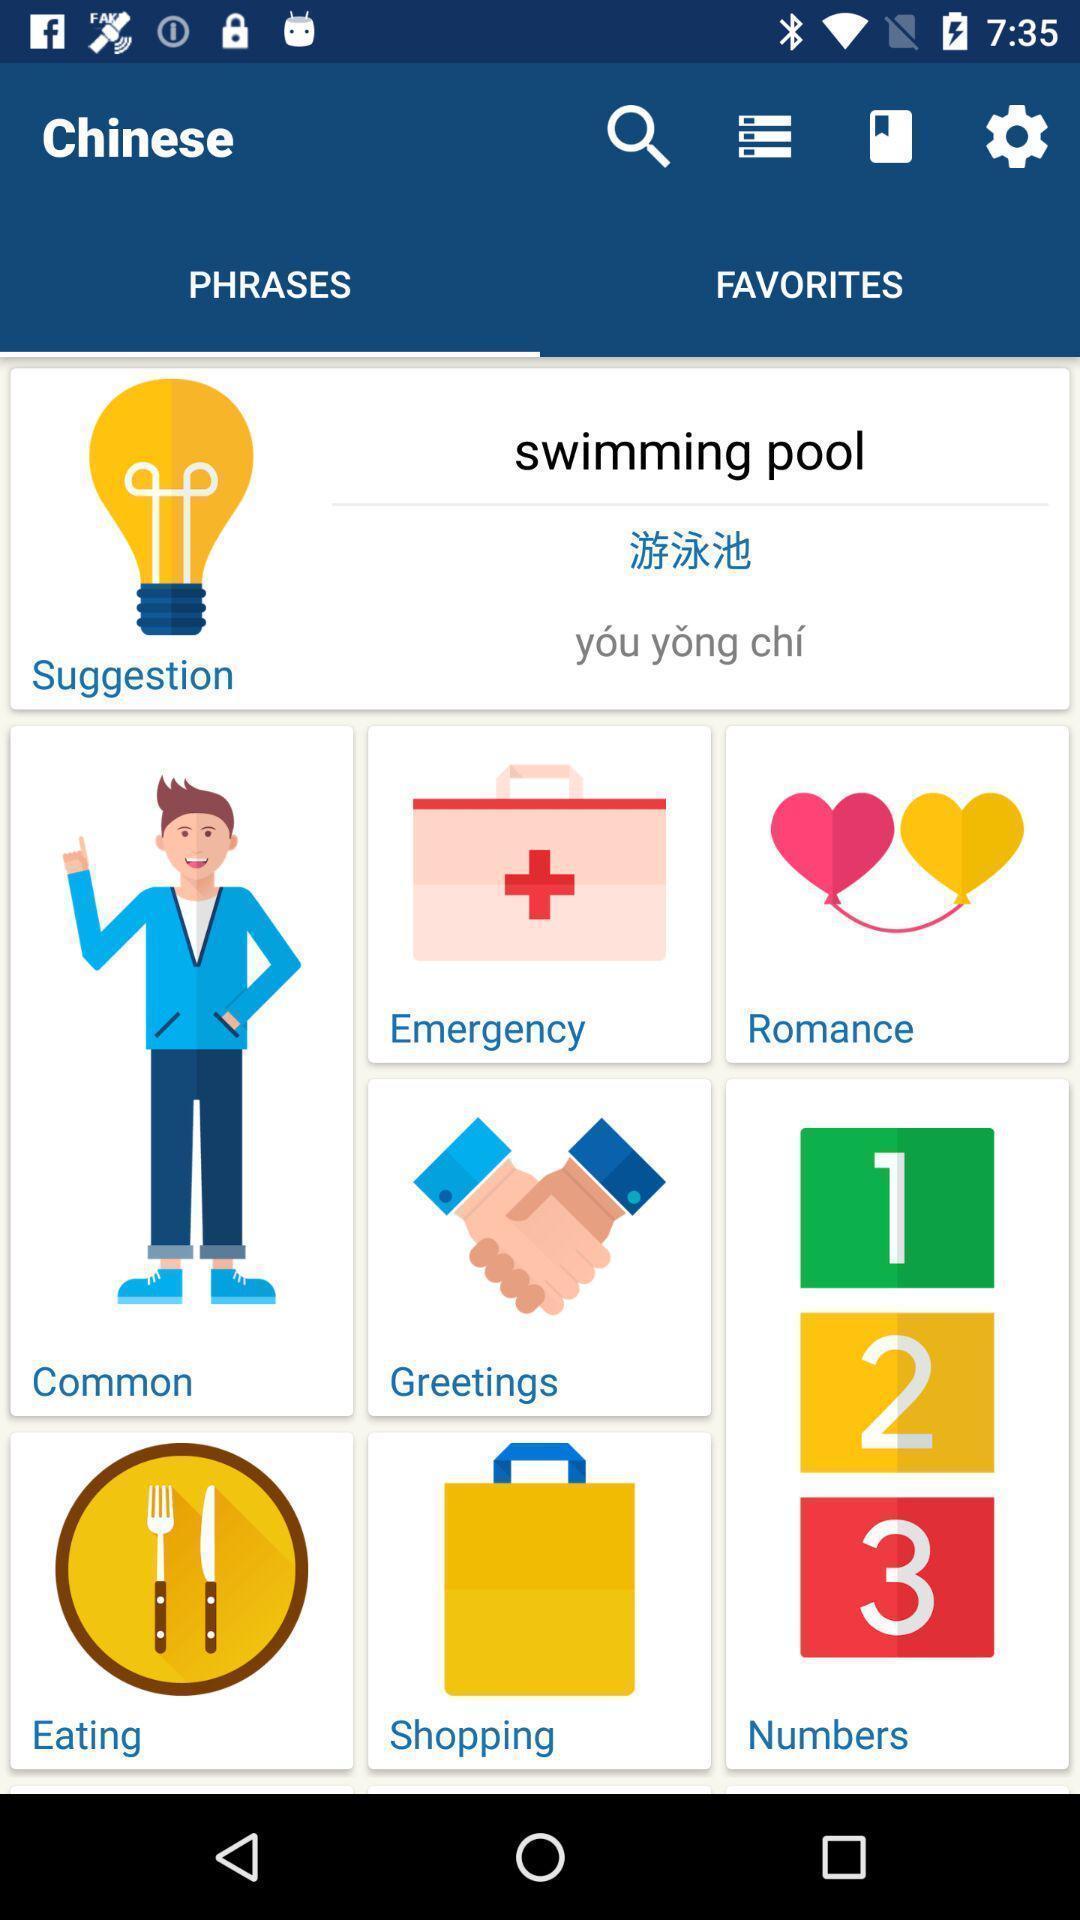Describe the visual elements of this screenshot. Screen displaying the phrases page with different categories. 